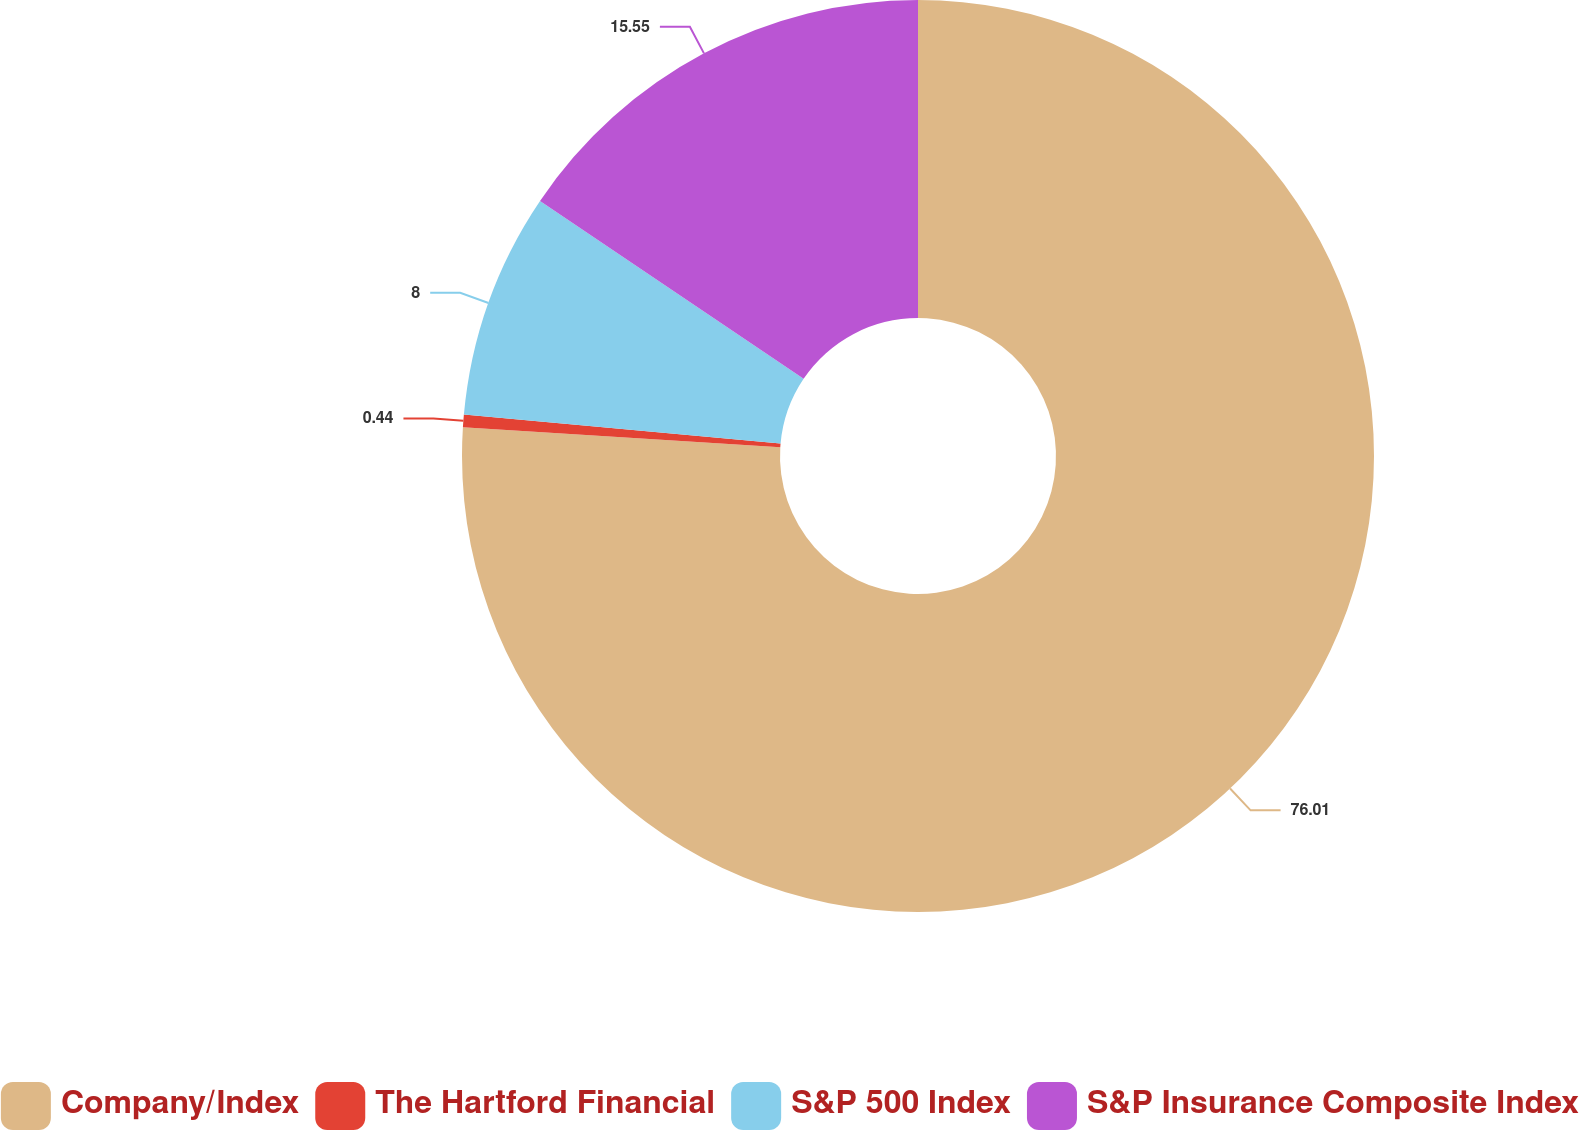Convert chart. <chart><loc_0><loc_0><loc_500><loc_500><pie_chart><fcel>Company/Index<fcel>The Hartford Financial<fcel>S&P 500 Index<fcel>S&P Insurance Composite Index<nl><fcel>76.0%<fcel>0.44%<fcel>8.0%<fcel>15.55%<nl></chart> 